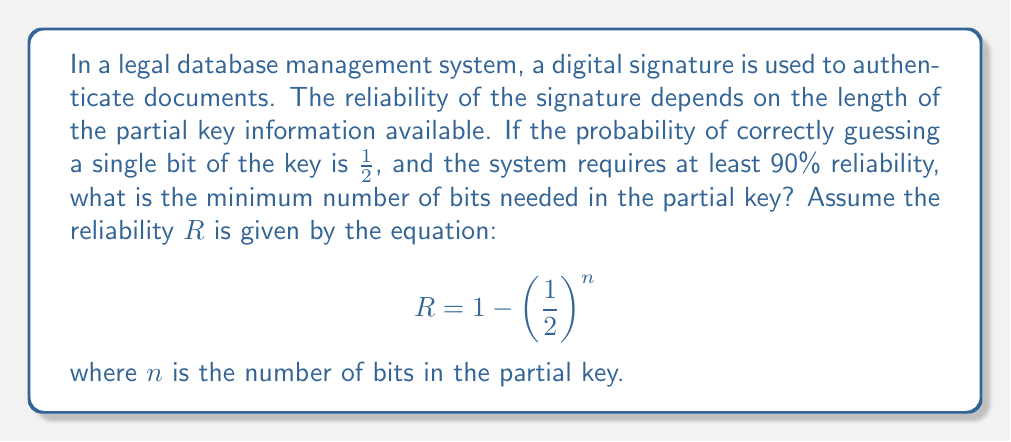Give your solution to this math problem. To solve this problem, we need to follow these steps:

1) We are given that the reliability $R$ should be at least 90%, or 0.90 in decimal form.

2) We need to find the minimum value of $n$ that satisfies the equation:

   $$0.90 \leq 1 - (\frac{1}{2})^n$$

3) Let's rearrange this inequality:

   $$(\frac{1}{2})^n \leq 1 - 0.90 = 0.10$$

4) Now, let's take the logarithm (base 2) of both sides:

   $$n \log_2(\frac{1}{2}) \leq \log_2(0.10)$$

5) Simplify: $\log_2(\frac{1}{2}) = -1$, so:

   $$-n \leq \log_2(0.10)$$

6) Solve for $n$:

   $$n \geq -\log_2(0.10) \approx 3.32$$

7) Since $n$ must be a whole number (we can't have a fractional bit), we round up to the nearest integer:

   $$n \geq 4$$

Therefore, the minimum number of bits needed in the partial key to ensure at least 90% reliability is 4.
Answer: 4 bits 